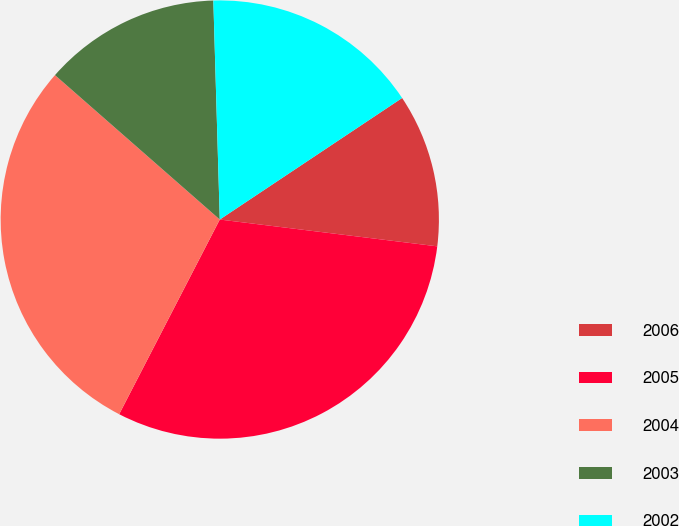<chart> <loc_0><loc_0><loc_500><loc_500><pie_chart><fcel>2006<fcel>2005<fcel>2004<fcel>2003<fcel>2002<nl><fcel>11.31%<fcel>30.64%<fcel>28.86%<fcel>13.08%<fcel>16.11%<nl></chart> 